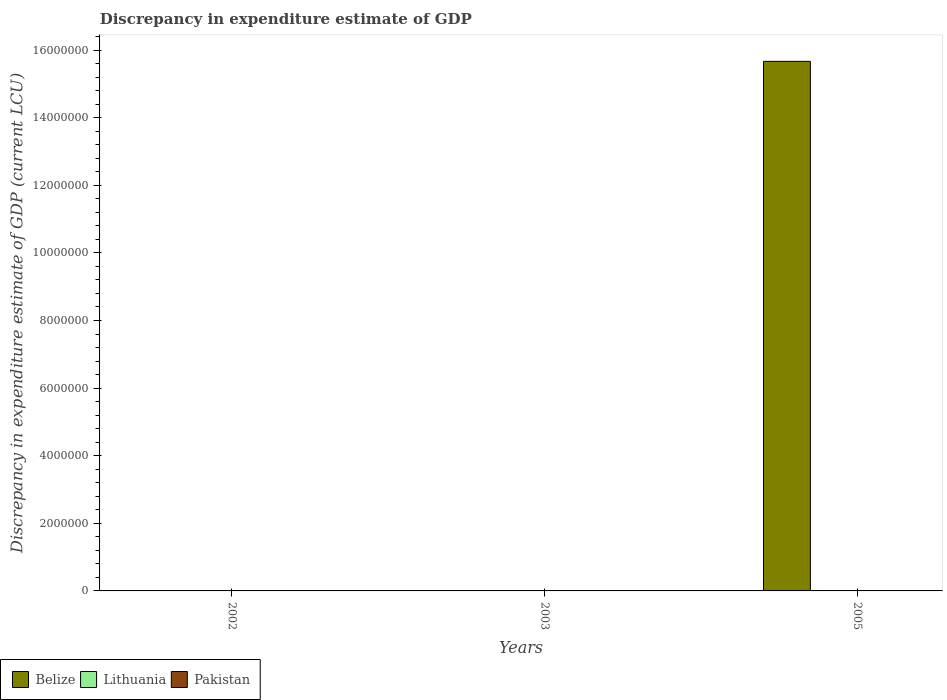How many different coloured bars are there?
Offer a terse response. 3. How many bars are there on the 2nd tick from the left?
Your answer should be compact. 2. How many bars are there on the 3rd tick from the right?
Your response must be concise. 1. In how many cases, is the number of bars for a given year not equal to the number of legend labels?
Provide a succinct answer. 3. Across all years, what is the maximum discrepancy in expenditure estimate of GDP in Pakistan?
Provide a short and direct response. 0. Across all years, what is the minimum discrepancy in expenditure estimate of GDP in Pakistan?
Keep it short and to the point. 0. In which year was the discrepancy in expenditure estimate of GDP in Lithuania maximum?
Your answer should be very brief. 2002. What is the total discrepancy in expenditure estimate of GDP in Belize in the graph?
Give a very brief answer. 1.57e+07. What is the difference between the discrepancy in expenditure estimate of GDP in Lithuania in 2002 and that in 2003?
Offer a very short reply. 0. What is the difference between the discrepancy in expenditure estimate of GDP in Pakistan in 2005 and the discrepancy in expenditure estimate of GDP in Lithuania in 2002?
Give a very brief answer. -100. What is the average discrepancy in expenditure estimate of GDP in Belize per year?
Your response must be concise. 5.22e+06. In the year 2003, what is the difference between the discrepancy in expenditure estimate of GDP in Lithuania and discrepancy in expenditure estimate of GDP in Pakistan?
Provide a succinct answer. 100. What is the difference between the highest and the lowest discrepancy in expenditure estimate of GDP in Belize?
Make the answer very short. 1.57e+07. Are all the bars in the graph horizontal?
Your response must be concise. No. How many years are there in the graph?
Your answer should be compact. 3. Does the graph contain any zero values?
Your answer should be compact. Yes. What is the title of the graph?
Your answer should be compact. Discrepancy in expenditure estimate of GDP. Does "Low & middle income" appear as one of the legend labels in the graph?
Give a very brief answer. No. What is the label or title of the X-axis?
Provide a short and direct response. Years. What is the label or title of the Y-axis?
Give a very brief answer. Discrepancy in expenditure estimate of GDP (current LCU). What is the Discrepancy in expenditure estimate of GDP (current LCU) of Belize in 2002?
Your answer should be compact. 0. What is the Discrepancy in expenditure estimate of GDP (current LCU) of Belize in 2003?
Your response must be concise. 0. What is the Discrepancy in expenditure estimate of GDP (current LCU) of Lithuania in 2003?
Make the answer very short. 100. What is the Discrepancy in expenditure estimate of GDP (current LCU) of Pakistan in 2003?
Give a very brief answer. 0. What is the Discrepancy in expenditure estimate of GDP (current LCU) of Belize in 2005?
Your response must be concise. 1.57e+07. What is the Discrepancy in expenditure estimate of GDP (current LCU) of Pakistan in 2005?
Provide a short and direct response. 0. Across all years, what is the maximum Discrepancy in expenditure estimate of GDP (current LCU) in Belize?
Your answer should be compact. 1.57e+07. Across all years, what is the maximum Discrepancy in expenditure estimate of GDP (current LCU) in Pakistan?
Provide a short and direct response. 0. Across all years, what is the minimum Discrepancy in expenditure estimate of GDP (current LCU) of Lithuania?
Ensure brevity in your answer.  0. What is the total Discrepancy in expenditure estimate of GDP (current LCU) in Belize in the graph?
Ensure brevity in your answer.  1.57e+07. What is the total Discrepancy in expenditure estimate of GDP (current LCU) in Lithuania in the graph?
Provide a succinct answer. 200. What is the difference between the Discrepancy in expenditure estimate of GDP (current LCU) in Lithuania in 2002 and that in 2003?
Make the answer very short. 0. What is the difference between the Discrepancy in expenditure estimate of GDP (current LCU) in Lithuania in 2002 and the Discrepancy in expenditure estimate of GDP (current LCU) in Pakistan in 2003?
Your answer should be compact. 100. What is the difference between the Discrepancy in expenditure estimate of GDP (current LCU) in Lithuania in 2002 and the Discrepancy in expenditure estimate of GDP (current LCU) in Pakistan in 2005?
Give a very brief answer. 100. What is the difference between the Discrepancy in expenditure estimate of GDP (current LCU) in Lithuania in 2003 and the Discrepancy in expenditure estimate of GDP (current LCU) in Pakistan in 2005?
Provide a succinct answer. 100. What is the average Discrepancy in expenditure estimate of GDP (current LCU) of Belize per year?
Offer a very short reply. 5.22e+06. What is the average Discrepancy in expenditure estimate of GDP (current LCU) in Lithuania per year?
Make the answer very short. 66.67. What is the average Discrepancy in expenditure estimate of GDP (current LCU) in Pakistan per year?
Provide a short and direct response. 0. In the year 2003, what is the difference between the Discrepancy in expenditure estimate of GDP (current LCU) of Lithuania and Discrepancy in expenditure estimate of GDP (current LCU) of Pakistan?
Ensure brevity in your answer.  100. In the year 2005, what is the difference between the Discrepancy in expenditure estimate of GDP (current LCU) in Belize and Discrepancy in expenditure estimate of GDP (current LCU) in Pakistan?
Your response must be concise. 1.57e+07. What is the difference between the highest and the lowest Discrepancy in expenditure estimate of GDP (current LCU) of Belize?
Provide a short and direct response. 1.57e+07. What is the difference between the highest and the lowest Discrepancy in expenditure estimate of GDP (current LCU) in Lithuania?
Provide a succinct answer. 100. 